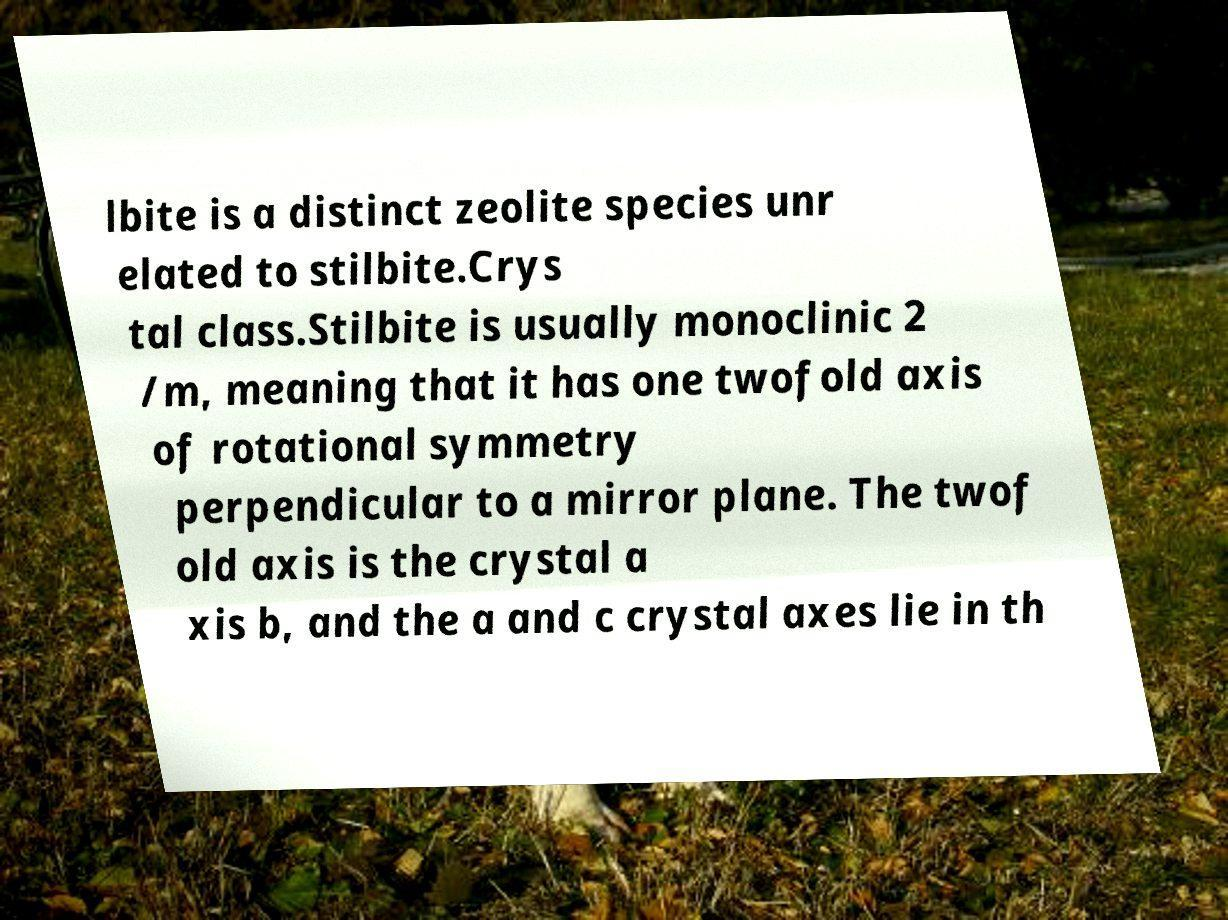Please read and relay the text visible in this image. What does it say? lbite is a distinct zeolite species unr elated to stilbite.Crys tal class.Stilbite is usually monoclinic 2 /m, meaning that it has one twofold axis of rotational symmetry perpendicular to a mirror plane. The twof old axis is the crystal a xis b, and the a and c crystal axes lie in th 